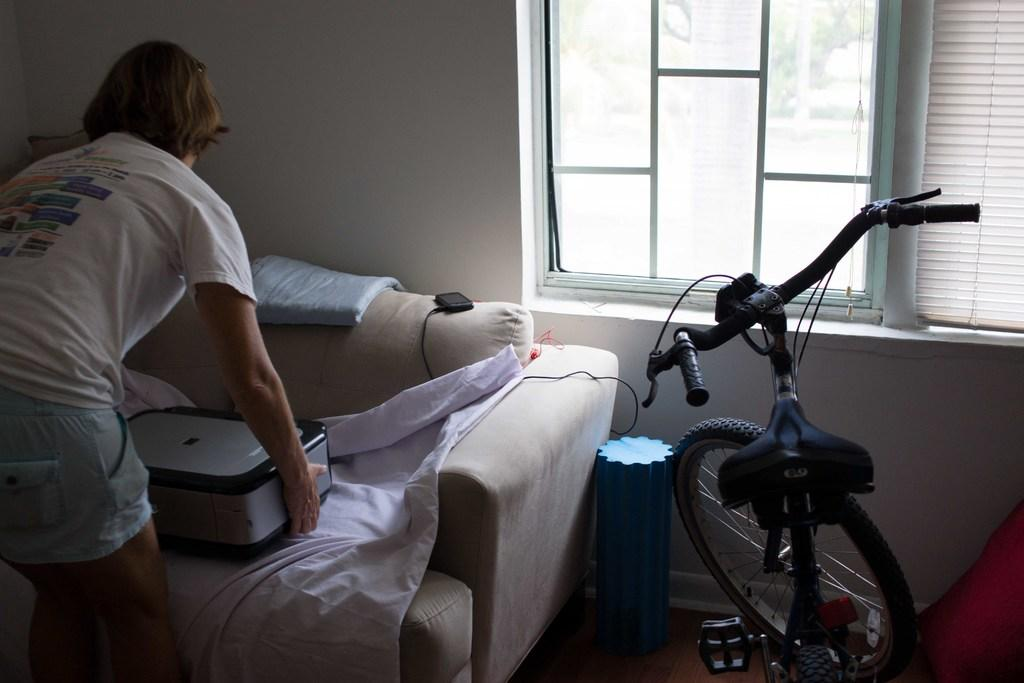What is the person in the image doing? The person is standing in the image and holding an object in their hands. Where is the person located in the image? The person is in the left corner of the image. What piece of furniture is present in the image? There is a sofa in the image. How is the sofa positioned in relation to the person? The sofa is in front of the person. What other object can be seen in the image? There is a bicycle in the image. Where is the bicycle located in the image? The bicycle is in the right corner of the image. What type of ink is the pig using to sign the approval document in the image? There is no pig or approval document present in the image. 